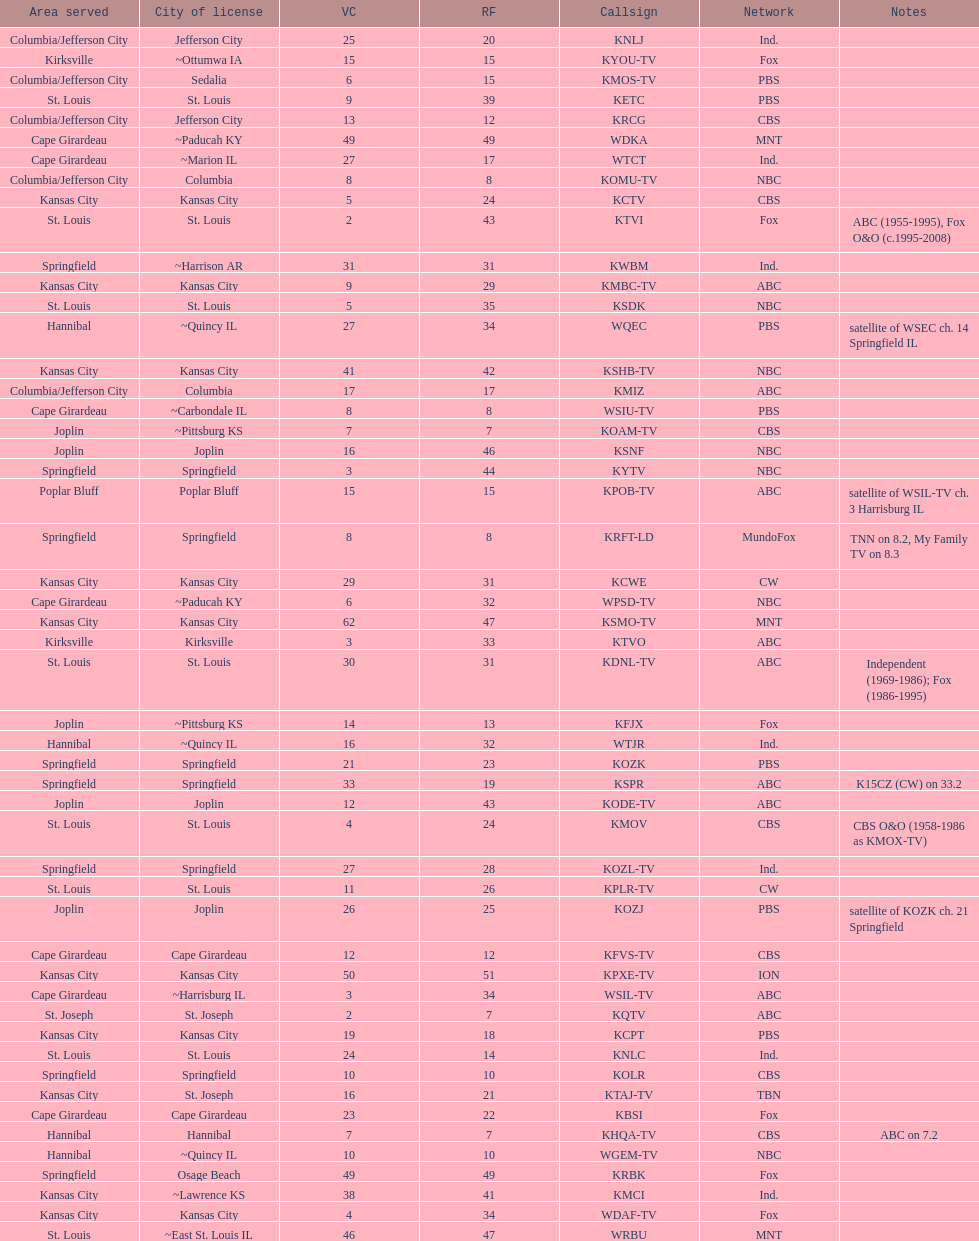How many are on the cbs network? 7. 